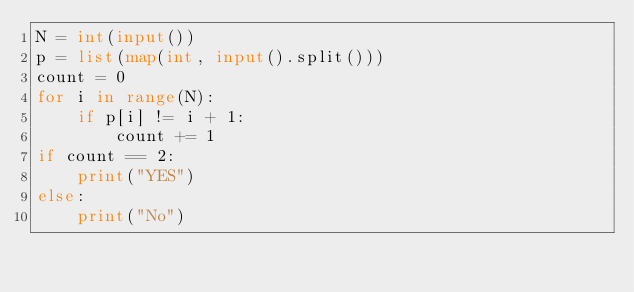Convert code to text. <code><loc_0><loc_0><loc_500><loc_500><_Python_>N = int(input())
p = list(map(int, input().split()))
count = 0
for i in range(N):
    if p[i] != i + 1:
        count += 1
if count == 2:
    print("YES")
else:
    print("No")</code> 